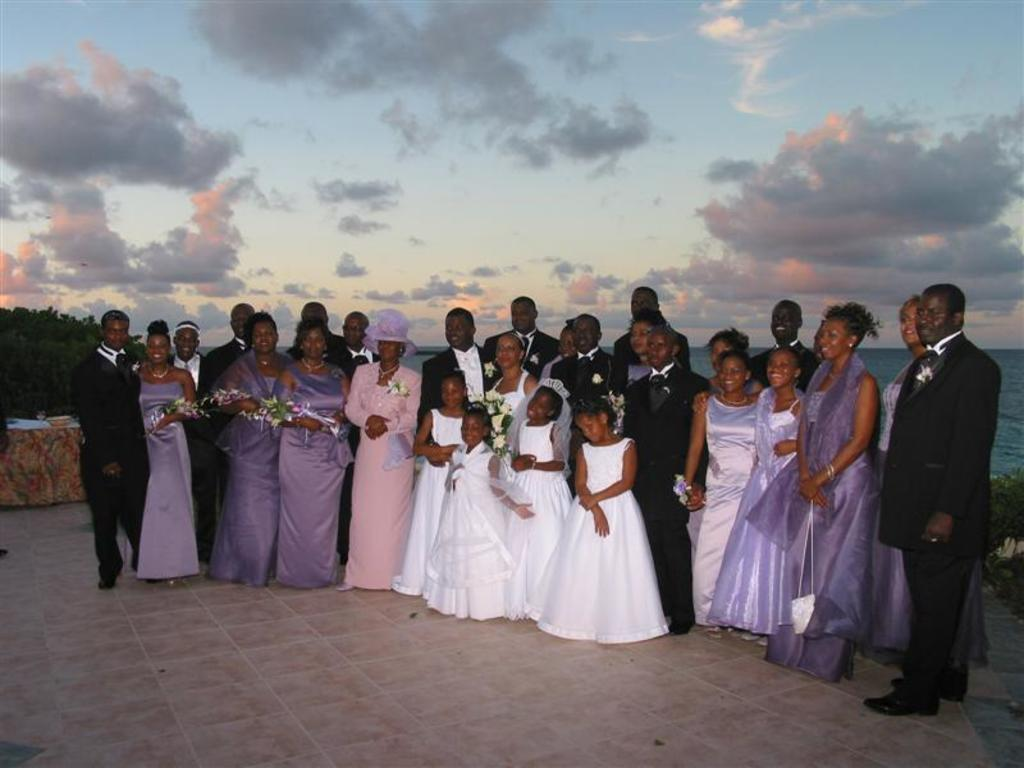What is happening in the image? There are people standing in the image. What can be seen on the left side of the image? There appears to be a table on the left side of the image. What is visible in the background of the image? Trees and water are visible in the background of the image. How would you describe the sky in the image? The sky is blue and cloudy. What shape is the balloon in the image? There is no balloon present in the image. What do the people in the image believe about the sky? The image does not provide information about the beliefs of the people in the image. 